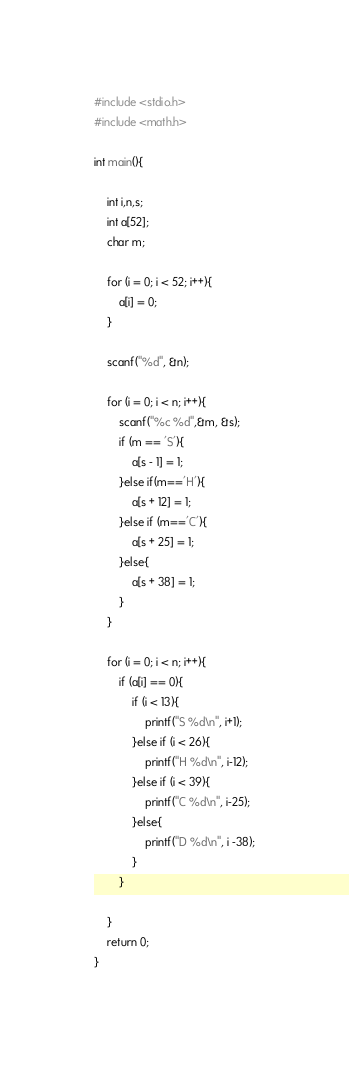Convert code to text. <code><loc_0><loc_0><loc_500><loc_500><_C_>#include <stdio.h>
#include <math.h>

int main(){
	
	int i,n,s;
	int a[52];
	char m;

	for (i = 0; i < 52; i++){
		a[i] = 0;
	}

	scanf("%d", &n);

	for (i = 0; i < n; i++){
		scanf("%c %d",&m, &s);
		if (m == 'S'){
			a[s - 1] = 1;
		}else if(m=='H'){
			a[s + 12] = 1;
		}else if (m=='C'){
			a[s + 25] = 1;
		}else{
			a[s + 38] = 1;
		}
	}

	for (i = 0; i < n; i++){
		if (a[i] == 0){
			if (i < 13){
				printf("S %d\n", i+1);
			}else if (i < 26){
				printf("H %d\n", i-12);
			}else if (i < 39){
				printf("C %d\n", i-25);
			}else{
				printf("D %d\n", i -38);
			}
		}
		
	}
	return 0;
}</code> 